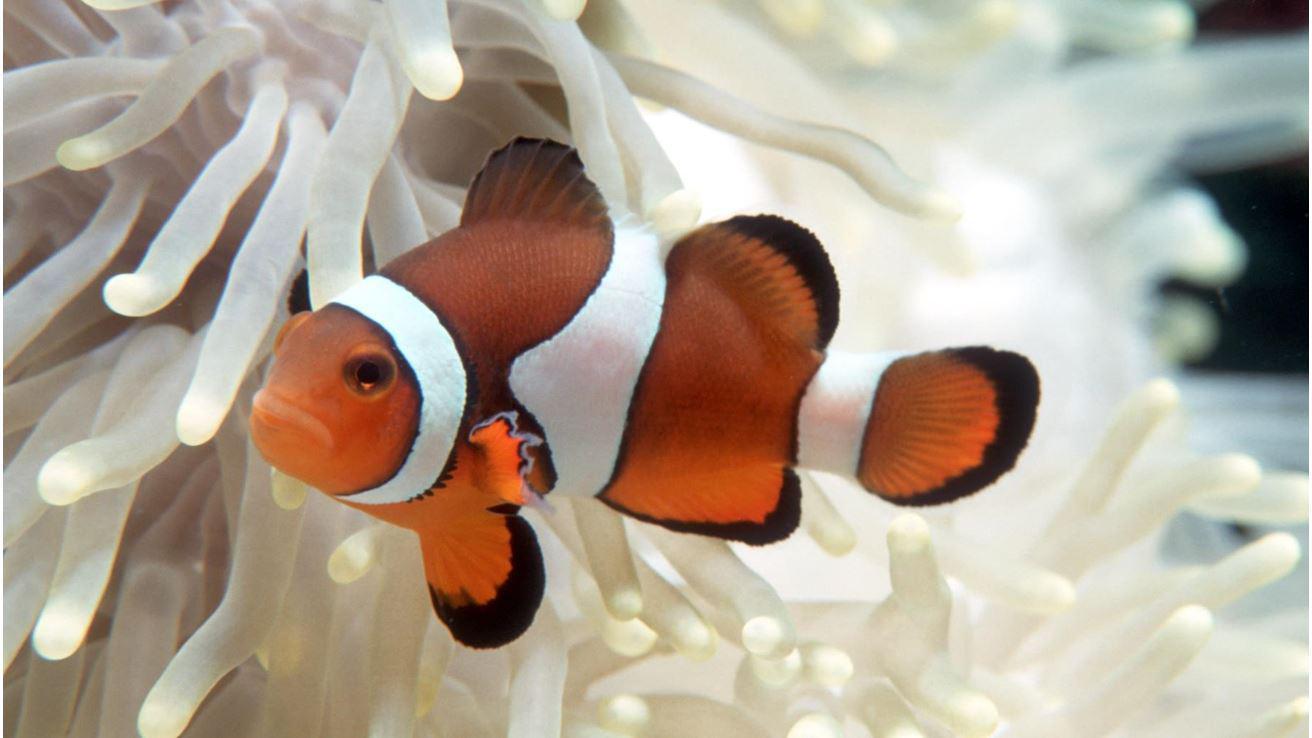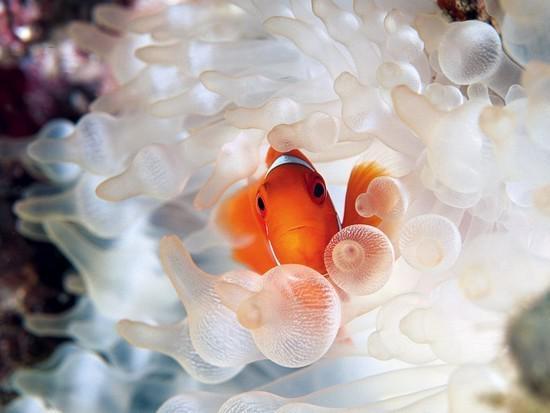The first image is the image on the left, the second image is the image on the right. Given the left and right images, does the statement "One image shows a clown fish facing fully forward and surrounded by nipple-like structures." hold true? Answer yes or no. Yes. 